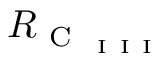Convert formula to latex. <formula><loc_0><loc_0><loc_500><loc_500>R _ { C _ { I I I } }</formula> 